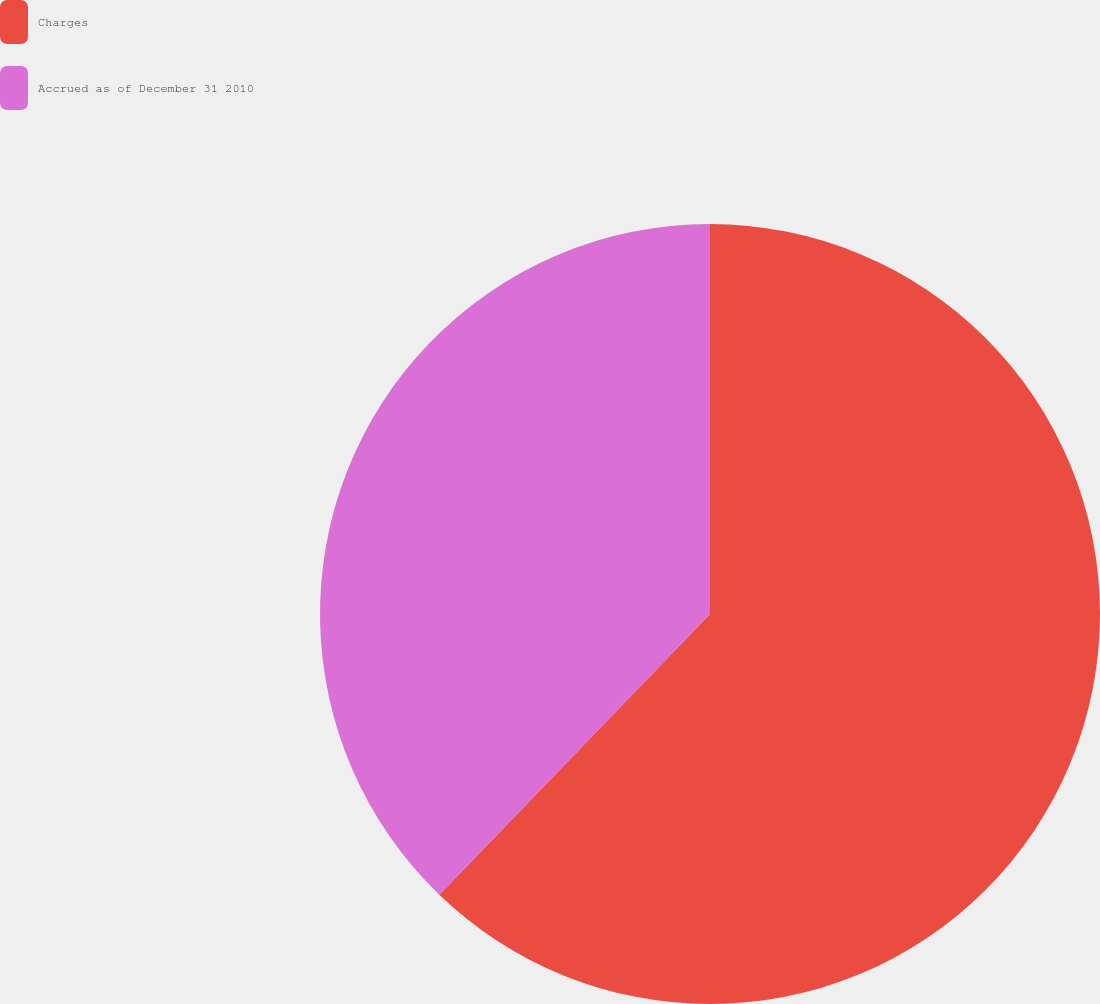Convert chart. <chart><loc_0><loc_0><loc_500><loc_500><pie_chart><fcel>Charges<fcel>Accrued as of December 31 2010<nl><fcel>62.21%<fcel>37.79%<nl></chart> 